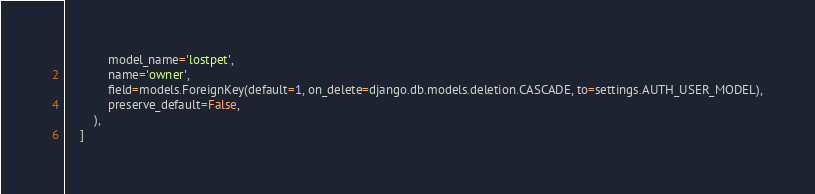Convert code to text. <code><loc_0><loc_0><loc_500><loc_500><_Python_>            model_name='lostpet',
            name='owner',
            field=models.ForeignKey(default=1, on_delete=django.db.models.deletion.CASCADE, to=settings.AUTH_USER_MODEL),
            preserve_default=False,
        ),
    ]
</code> 